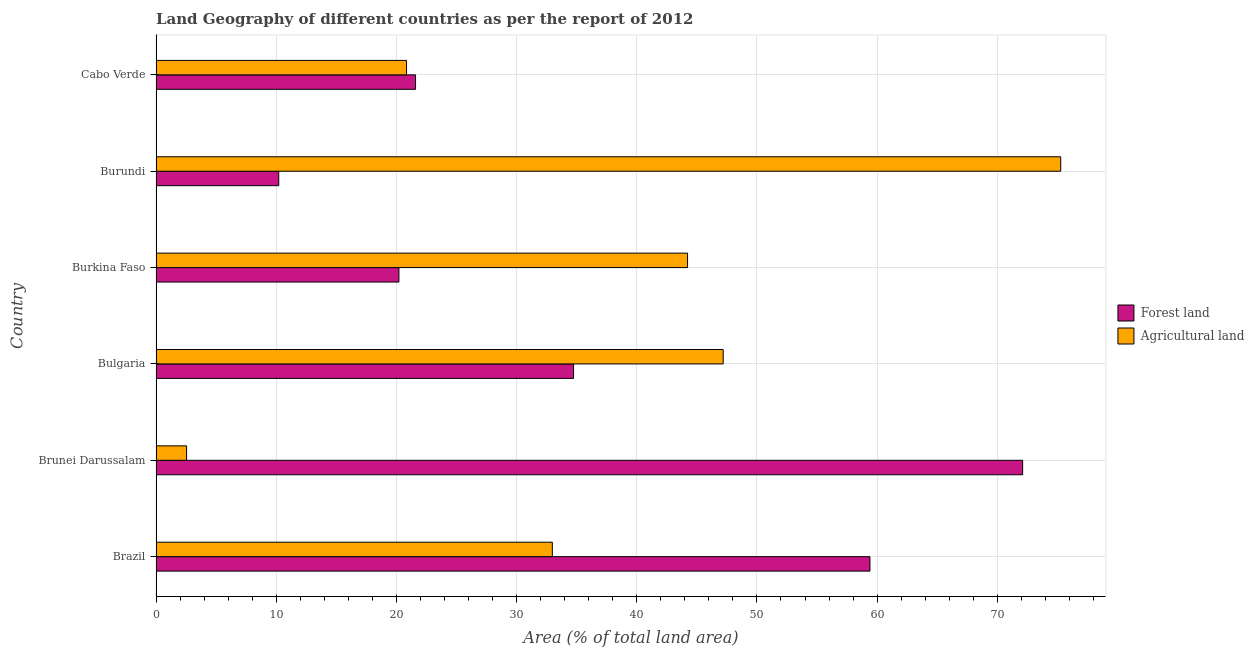Are the number of bars on each tick of the Y-axis equal?
Ensure brevity in your answer.  Yes. How many bars are there on the 5th tick from the bottom?
Keep it short and to the point. 2. What is the label of the 5th group of bars from the top?
Keep it short and to the point. Brunei Darussalam. In how many cases, is the number of bars for a given country not equal to the number of legend labels?
Offer a very short reply. 0. What is the percentage of land area under agriculture in Brazil?
Offer a terse response. 32.97. Across all countries, what is the maximum percentage of land area under forests?
Ensure brevity in your answer.  72.11. Across all countries, what is the minimum percentage of land area under agriculture?
Your answer should be very brief. 2.54. In which country was the percentage of land area under forests maximum?
Provide a succinct answer. Brunei Darussalam. In which country was the percentage of land area under forests minimum?
Keep it short and to the point. Burundi. What is the total percentage of land area under agriculture in the graph?
Offer a terse response. 223.05. What is the difference between the percentage of land area under agriculture in Brunei Darussalam and that in Burundi?
Ensure brevity in your answer.  -72.73. What is the difference between the percentage of land area under forests in Bulgaria and the percentage of land area under agriculture in Brazil?
Your answer should be compact. 1.77. What is the average percentage of land area under forests per country?
Keep it short and to the point. 36.38. What is the difference between the percentage of land area under agriculture and percentage of land area under forests in Brunei Darussalam?
Ensure brevity in your answer.  -69.56. What is the ratio of the percentage of land area under agriculture in Burkina Faso to that in Cabo Verde?
Provide a succinct answer. 2.12. Is the difference between the percentage of land area under agriculture in Bulgaria and Burkina Faso greater than the difference between the percentage of land area under forests in Bulgaria and Burkina Faso?
Offer a very short reply. No. What is the difference between the highest and the second highest percentage of land area under agriculture?
Your answer should be compact. 28.08. What is the difference between the highest and the lowest percentage of land area under agriculture?
Make the answer very short. 72.73. In how many countries, is the percentage of land area under forests greater than the average percentage of land area under forests taken over all countries?
Provide a succinct answer. 2. Is the sum of the percentage of land area under agriculture in Burkina Faso and Cabo Verde greater than the maximum percentage of land area under forests across all countries?
Your response must be concise. No. What does the 2nd bar from the top in Burundi represents?
Your answer should be compact. Forest land. What does the 1st bar from the bottom in Cabo Verde represents?
Give a very brief answer. Forest land. How many countries are there in the graph?
Ensure brevity in your answer.  6. What is the difference between two consecutive major ticks on the X-axis?
Your answer should be very brief. 10. Are the values on the major ticks of X-axis written in scientific E-notation?
Provide a short and direct response. No. Does the graph contain any zero values?
Provide a succinct answer. No. Does the graph contain grids?
Provide a succinct answer. Yes. Where does the legend appear in the graph?
Offer a terse response. Center right. How many legend labels are there?
Provide a succinct answer. 2. How are the legend labels stacked?
Your answer should be compact. Vertical. What is the title of the graph?
Your answer should be compact. Land Geography of different countries as per the report of 2012. What is the label or title of the X-axis?
Your answer should be very brief. Area (% of total land area). What is the Area (% of total land area) of Forest land in Brazil?
Keep it short and to the point. 59.4. What is the Area (% of total land area) in Agricultural land in Brazil?
Your answer should be compact. 32.97. What is the Area (% of total land area) in Forest land in Brunei Darussalam?
Offer a terse response. 72.11. What is the Area (% of total land area) in Agricultural land in Brunei Darussalam?
Offer a very short reply. 2.54. What is the Area (% of total land area) in Forest land in Bulgaria?
Offer a terse response. 34.74. What is the Area (% of total land area) in Agricultural land in Bulgaria?
Your answer should be compact. 47.19. What is the Area (% of total land area) of Forest land in Burkina Faso?
Your response must be concise. 20.21. What is the Area (% of total land area) of Agricultural land in Burkina Faso?
Your answer should be very brief. 44.23. What is the Area (% of total land area) of Forest land in Burundi?
Offer a very short reply. 10.21. What is the Area (% of total land area) of Agricultural land in Burundi?
Your answer should be very brief. 75.27. What is the Area (% of total land area) of Forest land in Cabo Verde?
Your response must be concise. 21.59. What is the Area (% of total land area) of Agricultural land in Cabo Verde?
Give a very brief answer. 20.84. Across all countries, what is the maximum Area (% of total land area) of Forest land?
Keep it short and to the point. 72.11. Across all countries, what is the maximum Area (% of total land area) in Agricultural land?
Give a very brief answer. 75.27. Across all countries, what is the minimum Area (% of total land area) in Forest land?
Offer a very short reply. 10.21. Across all countries, what is the minimum Area (% of total land area) in Agricultural land?
Your response must be concise. 2.54. What is the total Area (% of total land area) of Forest land in the graph?
Offer a very short reply. 218.26. What is the total Area (% of total land area) in Agricultural land in the graph?
Offer a terse response. 223.05. What is the difference between the Area (% of total land area) in Forest land in Brazil and that in Brunei Darussalam?
Offer a terse response. -12.7. What is the difference between the Area (% of total land area) in Agricultural land in Brazil and that in Brunei Darussalam?
Your response must be concise. 30.43. What is the difference between the Area (% of total land area) in Forest land in Brazil and that in Bulgaria?
Your response must be concise. 24.66. What is the difference between the Area (% of total land area) in Agricultural land in Brazil and that in Bulgaria?
Offer a terse response. -14.22. What is the difference between the Area (% of total land area) of Forest land in Brazil and that in Burkina Faso?
Ensure brevity in your answer.  39.19. What is the difference between the Area (% of total land area) in Agricultural land in Brazil and that in Burkina Faso?
Offer a terse response. -11.25. What is the difference between the Area (% of total land area) of Forest land in Brazil and that in Burundi?
Keep it short and to the point. 49.19. What is the difference between the Area (% of total land area) in Agricultural land in Brazil and that in Burundi?
Provide a short and direct response. -42.3. What is the difference between the Area (% of total land area) in Forest land in Brazil and that in Cabo Verde?
Ensure brevity in your answer.  37.81. What is the difference between the Area (% of total land area) in Agricultural land in Brazil and that in Cabo Verde?
Make the answer very short. 12.13. What is the difference between the Area (% of total land area) in Forest land in Brunei Darussalam and that in Bulgaria?
Ensure brevity in your answer.  37.37. What is the difference between the Area (% of total land area) in Agricultural land in Brunei Darussalam and that in Bulgaria?
Your answer should be compact. -44.65. What is the difference between the Area (% of total land area) in Forest land in Brunei Darussalam and that in Burkina Faso?
Your answer should be very brief. 51.9. What is the difference between the Area (% of total land area) in Agricultural land in Brunei Darussalam and that in Burkina Faso?
Keep it short and to the point. -41.68. What is the difference between the Area (% of total land area) of Forest land in Brunei Darussalam and that in Burundi?
Provide a short and direct response. 61.9. What is the difference between the Area (% of total land area) in Agricultural land in Brunei Darussalam and that in Burundi?
Offer a terse response. -72.73. What is the difference between the Area (% of total land area) of Forest land in Brunei Darussalam and that in Cabo Verde?
Provide a short and direct response. 50.51. What is the difference between the Area (% of total land area) of Agricultural land in Brunei Darussalam and that in Cabo Verde?
Ensure brevity in your answer.  -18.3. What is the difference between the Area (% of total land area) in Forest land in Bulgaria and that in Burkina Faso?
Give a very brief answer. 14.53. What is the difference between the Area (% of total land area) in Agricultural land in Bulgaria and that in Burkina Faso?
Keep it short and to the point. 2.97. What is the difference between the Area (% of total land area) of Forest land in Bulgaria and that in Burundi?
Offer a very short reply. 24.53. What is the difference between the Area (% of total land area) of Agricultural land in Bulgaria and that in Burundi?
Provide a short and direct response. -28.08. What is the difference between the Area (% of total land area) in Forest land in Bulgaria and that in Cabo Verde?
Keep it short and to the point. 13.15. What is the difference between the Area (% of total land area) in Agricultural land in Bulgaria and that in Cabo Verde?
Your answer should be very brief. 26.35. What is the difference between the Area (% of total land area) of Forest land in Burkina Faso and that in Burundi?
Ensure brevity in your answer.  10. What is the difference between the Area (% of total land area) in Agricultural land in Burkina Faso and that in Burundi?
Offer a terse response. -31.05. What is the difference between the Area (% of total land area) of Forest land in Burkina Faso and that in Cabo Verde?
Provide a succinct answer. -1.38. What is the difference between the Area (% of total land area) of Agricultural land in Burkina Faso and that in Cabo Verde?
Ensure brevity in your answer.  23.38. What is the difference between the Area (% of total land area) of Forest land in Burundi and that in Cabo Verde?
Provide a short and direct response. -11.38. What is the difference between the Area (% of total land area) of Agricultural land in Burundi and that in Cabo Verde?
Give a very brief answer. 54.43. What is the difference between the Area (% of total land area) of Forest land in Brazil and the Area (% of total land area) of Agricultural land in Brunei Darussalam?
Your answer should be very brief. 56.86. What is the difference between the Area (% of total land area) in Forest land in Brazil and the Area (% of total land area) in Agricultural land in Bulgaria?
Offer a very short reply. 12.21. What is the difference between the Area (% of total land area) of Forest land in Brazil and the Area (% of total land area) of Agricultural land in Burkina Faso?
Provide a succinct answer. 15.18. What is the difference between the Area (% of total land area) of Forest land in Brazil and the Area (% of total land area) of Agricultural land in Burundi?
Make the answer very short. -15.87. What is the difference between the Area (% of total land area) in Forest land in Brazil and the Area (% of total land area) in Agricultural land in Cabo Verde?
Your answer should be very brief. 38.56. What is the difference between the Area (% of total land area) in Forest land in Brunei Darussalam and the Area (% of total land area) in Agricultural land in Bulgaria?
Your response must be concise. 24.92. What is the difference between the Area (% of total land area) in Forest land in Brunei Darussalam and the Area (% of total land area) in Agricultural land in Burkina Faso?
Offer a terse response. 27.88. What is the difference between the Area (% of total land area) in Forest land in Brunei Darussalam and the Area (% of total land area) in Agricultural land in Burundi?
Give a very brief answer. -3.17. What is the difference between the Area (% of total land area) of Forest land in Brunei Darussalam and the Area (% of total land area) of Agricultural land in Cabo Verde?
Keep it short and to the point. 51.26. What is the difference between the Area (% of total land area) in Forest land in Bulgaria and the Area (% of total land area) in Agricultural land in Burkina Faso?
Provide a short and direct response. -9.48. What is the difference between the Area (% of total land area) in Forest land in Bulgaria and the Area (% of total land area) in Agricultural land in Burundi?
Your answer should be compact. -40.53. What is the difference between the Area (% of total land area) of Forest land in Bulgaria and the Area (% of total land area) of Agricultural land in Cabo Verde?
Your answer should be very brief. 13.9. What is the difference between the Area (% of total land area) of Forest land in Burkina Faso and the Area (% of total land area) of Agricultural land in Burundi?
Provide a succinct answer. -55.06. What is the difference between the Area (% of total land area) of Forest land in Burkina Faso and the Area (% of total land area) of Agricultural land in Cabo Verde?
Your answer should be compact. -0.63. What is the difference between the Area (% of total land area) in Forest land in Burundi and the Area (% of total land area) in Agricultural land in Cabo Verde?
Make the answer very short. -10.63. What is the average Area (% of total land area) of Forest land per country?
Give a very brief answer. 36.38. What is the average Area (% of total land area) of Agricultural land per country?
Your answer should be very brief. 37.17. What is the difference between the Area (% of total land area) of Forest land and Area (% of total land area) of Agricultural land in Brazil?
Your response must be concise. 26.43. What is the difference between the Area (% of total land area) of Forest land and Area (% of total land area) of Agricultural land in Brunei Darussalam?
Your answer should be compact. 69.56. What is the difference between the Area (% of total land area) in Forest land and Area (% of total land area) in Agricultural land in Bulgaria?
Your response must be concise. -12.45. What is the difference between the Area (% of total land area) in Forest land and Area (% of total land area) in Agricultural land in Burkina Faso?
Provide a short and direct response. -24.02. What is the difference between the Area (% of total land area) of Forest land and Area (% of total land area) of Agricultural land in Burundi?
Offer a terse response. -65.06. What is the difference between the Area (% of total land area) in Forest land and Area (% of total land area) in Agricultural land in Cabo Verde?
Offer a terse response. 0.75. What is the ratio of the Area (% of total land area) in Forest land in Brazil to that in Brunei Darussalam?
Your response must be concise. 0.82. What is the ratio of the Area (% of total land area) in Agricultural land in Brazil to that in Brunei Darussalam?
Ensure brevity in your answer.  12.97. What is the ratio of the Area (% of total land area) in Forest land in Brazil to that in Bulgaria?
Your response must be concise. 1.71. What is the ratio of the Area (% of total land area) in Agricultural land in Brazil to that in Bulgaria?
Provide a short and direct response. 0.7. What is the ratio of the Area (% of total land area) in Forest land in Brazil to that in Burkina Faso?
Your answer should be very brief. 2.94. What is the ratio of the Area (% of total land area) in Agricultural land in Brazil to that in Burkina Faso?
Offer a very short reply. 0.75. What is the ratio of the Area (% of total land area) of Forest land in Brazil to that in Burundi?
Provide a succinct answer. 5.82. What is the ratio of the Area (% of total land area) of Agricultural land in Brazil to that in Burundi?
Your response must be concise. 0.44. What is the ratio of the Area (% of total land area) of Forest land in Brazil to that in Cabo Verde?
Offer a terse response. 2.75. What is the ratio of the Area (% of total land area) in Agricultural land in Brazil to that in Cabo Verde?
Your response must be concise. 1.58. What is the ratio of the Area (% of total land area) in Forest land in Brunei Darussalam to that in Bulgaria?
Offer a very short reply. 2.08. What is the ratio of the Area (% of total land area) in Agricultural land in Brunei Darussalam to that in Bulgaria?
Provide a succinct answer. 0.05. What is the ratio of the Area (% of total land area) in Forest land in Brunei Darussalam to that in Burkina Faso?
Your response must be concise. 3.57. What is the ratio of the Area (% of total land area) of Agricultural land in Brunei Darussalam to that in Burkina Faso?
Your answer should be very brief. 0.06. What is the ratio of the Area (% of total land area) in Forest land in Brunei Darussalam to that in Burundi?
Your response must be concise. 7.06. What is the ratio of the Area (% of total land area) in Agricultural land in Brunei Darussalam to that in Burundi?
Offer a very short reply. 0.03. What is the ratio of the Area (% of total land area) in Forest land in Brunei Darussalam to that in Cabo Verde?
Ensure brevity in your answer.  3.34. What is the ratio of the Area (% of total land area) in Agricultural land in Brunei Darussalam to that in Cabo Verde?
Provide a succinct answer. 0.12. What is the ratio of the Area (% of total land area) of Forest land in Bulgaria to that in Burkina Faso?
Give a very brief answer. 1.72. What is the ratio of the Area (% of total land area) of Agricultural land in Bulgaria to that in Burkina Faso?
Your answer should be compact. 1.07. What is the ratio of the Area (% of total land area) in Forest land in Bulgaria to that in Burundi?
Offer a very short reply. 3.4. What is the ratio of the Area (% of total land area) of Agricultural land in Bulgaria to that in Burundi?
Your answer should be very brief. 0.63. What is the ratio of the Area (% of total land area) in Forest land in Bulgaria to that in Cabo Verde?
Keep it short and to the point. 1.61. What is the ratio of the Area (% of total land area) in Agricultural land in Bulgaria to that in Cabo Verde?
Offer a terse response. 2.26. What is the ratio of the Area (% of total land area) of Forest land in Burkina Faso to that in Burundi?
Offer a very short reply. 1.98. What is the ratio of the Area (% of total land area) of Agricultural land in Burkina Faso to that in Burundi?
Provide a short and direct response. 0.59. What is the ratio of the Area (% of total land area) of Forest land in Burkina Faso to that in Cabo Verde?
Offer a very short reply. 0.94. What is the ratio of the Area (% of total land area) in Agricultural land in Burkina Faso to that in Cabo Verde?
Your answer should be compact. 2.12. What is the ratio of the Area (% of total land area) of Forest land in Burundi to that in Cabo Verde?
Ensure brevity in your answer.  0.47. What is the ratio of the Area (% of total land area) of Agricultural land in Burundi to that in Cabo Verde?
Offer a terse response. 3.61. What is the difference between the highest and the second highest Area (% of total land area) of Forest land?
Give a very brief answer. 12.7. What is the difference between the highest and the second highest Area (% of total land area) in Agricultural land?
Offer a very short reply. 28.08. What is the difference between the highest and the lowest Area (% of total land area) in Forest land?
Provide a succinct answer. 61.9. What is the difference between the highest and the lowest Area (% of total land area) in Agricultural land?
Offer a very short reply. 72.73. 